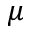<formula> <loc_0><loc_0><loc_500><loc_500>\mu</formula> 